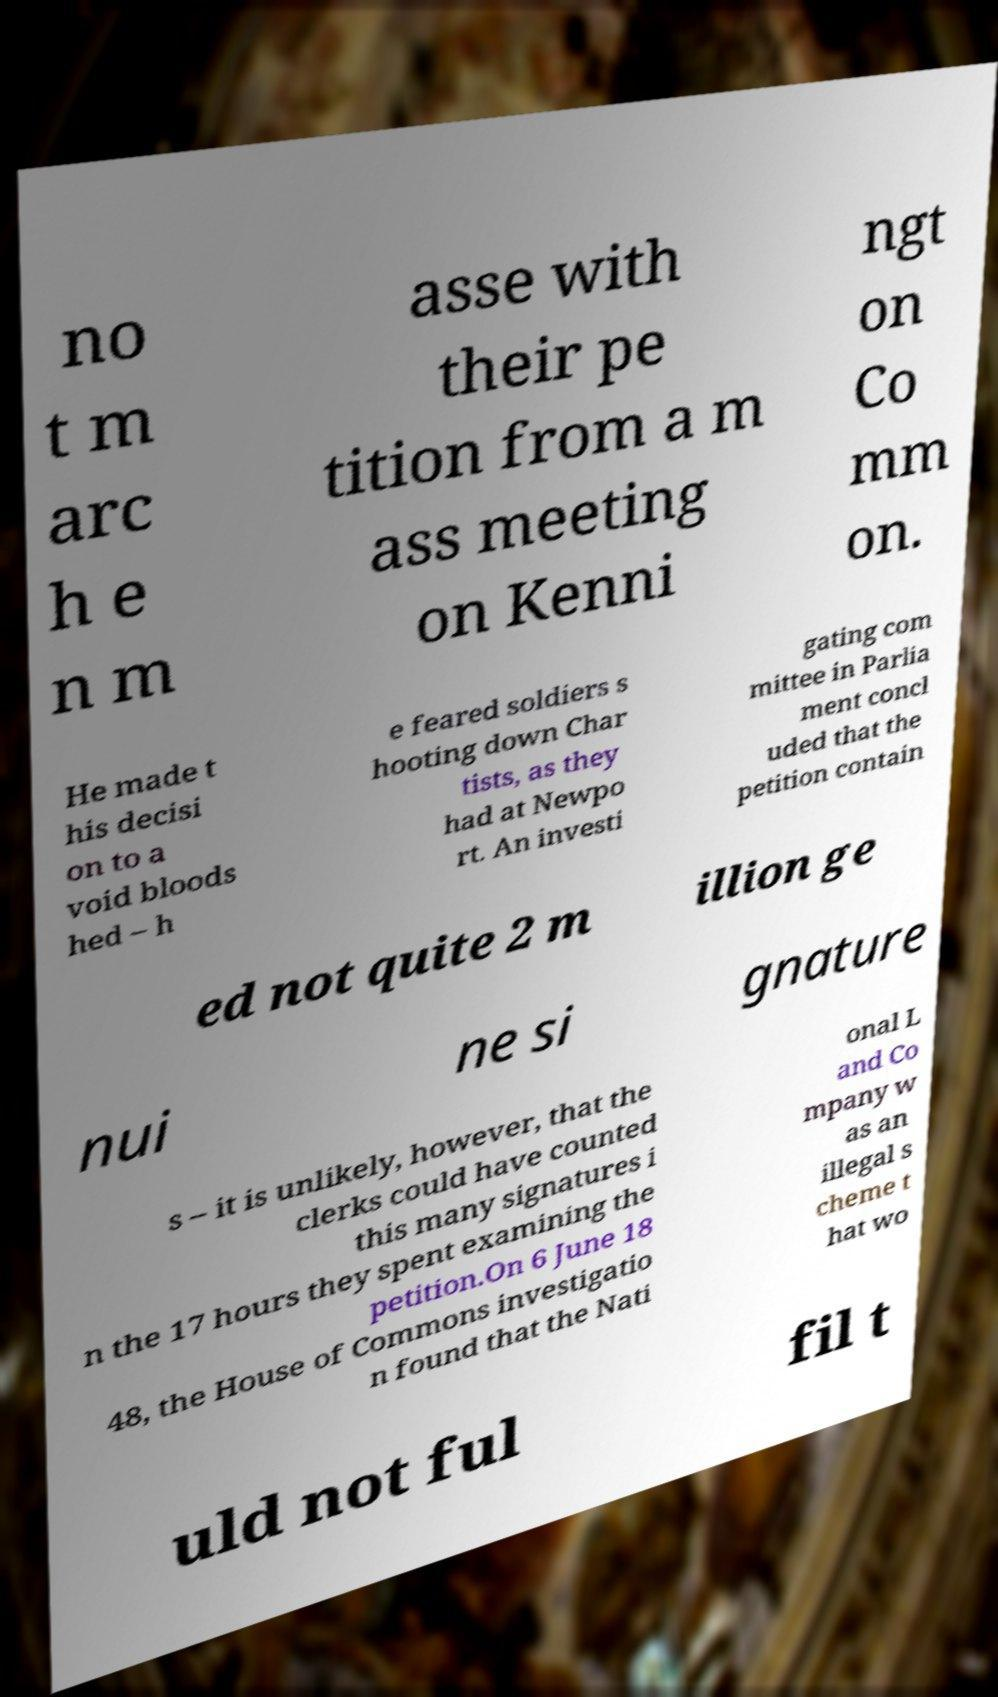There's text embedded in this image that I need extracted. Can you transcribe it verbatim? no t m arc h e n m asse with their pe tition from a m ass meeting on Kenni ngt on Co mm on. He made t his decisi on to a void bloods hed – h e feared soldiers s hooting down Char tists, as they had at Newpo rt. An investi gating com mittee in Parlia ment concl uded that the petition contain ed not quite 2 m illion ge nui ne si gnature s – it is unlikely, however, that the clerks could have counted this many signatures i n the 17 hours they spent examining the petition.On 6 June 18 48, the House of Commons investigatio n found that the Nati onal L and Co mpany w as an illegal s cheme t hat wo uld not ful fil t 